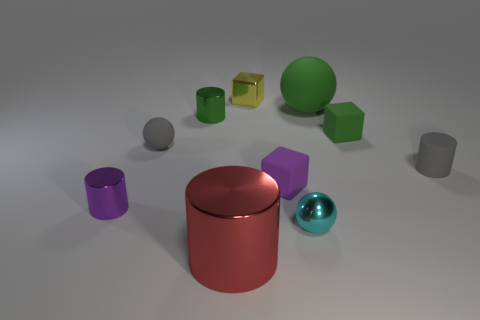Subtract all metallic blocks. How many blocks are left? 2 Subtract 1 cubes. How many cubes are left? 2 Subtract all green balls. How many balls are left? 2 Subtract all blocks. How many objects are left? 7 Subtract all purple cubes. Subtract all cyan cylinders. How many cubes are left? 2 Subtract all cyan cylinders. How many green spheres are left? 1 Subtract all purple matte blocks. Subtract all small metal spheres. How many objects are left? 8 Add 6 matte cylinders. How many matte cylinders are left? 7 Add 1 tiny purple shiny things. How many tiny purple shiny things exist? 2 Subtract 1 purple cylinders. How many objects are left? 9 